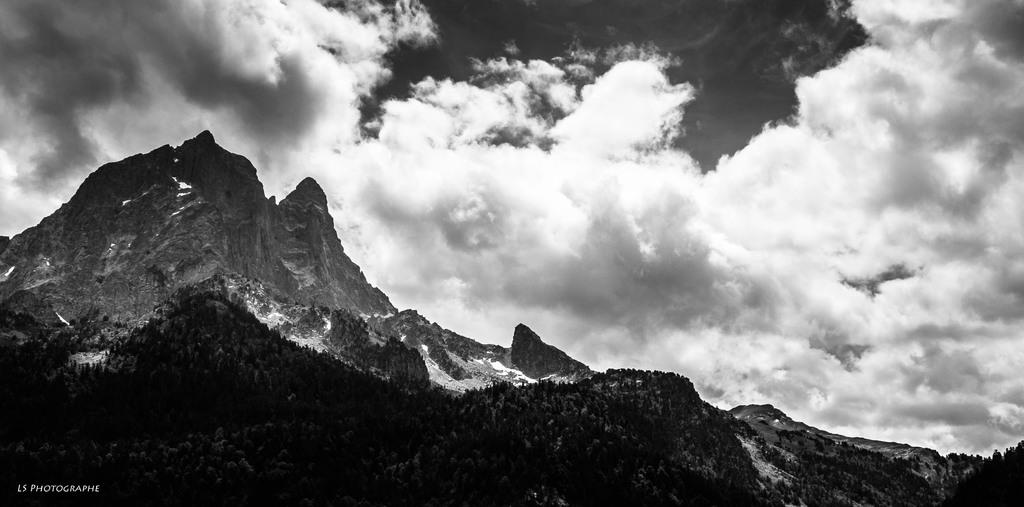What can be seen in the bottom left corner of the image? There is a watermark in the bottom left corner of the image. What type of natural landscape is visible in the background of the image? There are mountains in the background of the image. What is present in the sky in the image? There are clouds in the sky in the image. What type of hook or crook is being used by the carpenter in the image? There is no carpenter or any tools present in the image; it features mountains and clouds in the sky. 